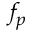Convert formula to latex. <formula><loc_0><loc_0><loc_500><loc_500>f _ { p }</formula> 